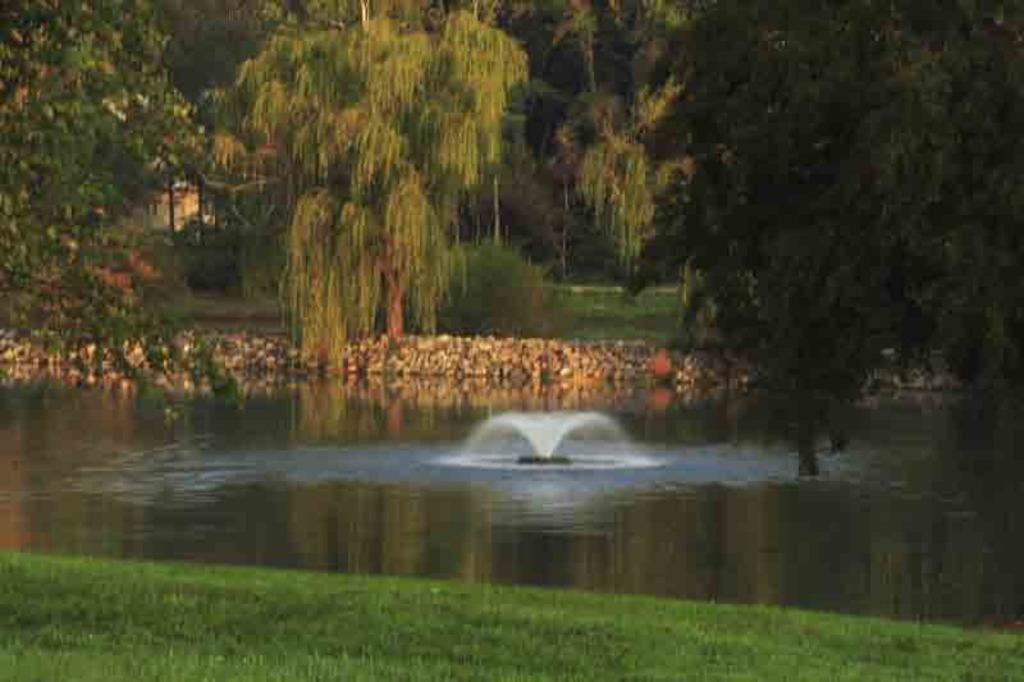What is the main feature in the center of the image? There is a fountain in the center of the image. What body of water is present in the image? There is water in a pond in the image. What type of terrain is visible in the foreground of the image? There is a grassy field in the foreground of the image. What can be seen in the background of the image? There is a group of trees and rocks visible in the background of the image. What type of voice can be heard coming from the fountain in the image? There is no voice present in the image; it is a visual representation featuring a fountain, water in a pond, a grassy field, a group of trees, and rocks visible in the background. 